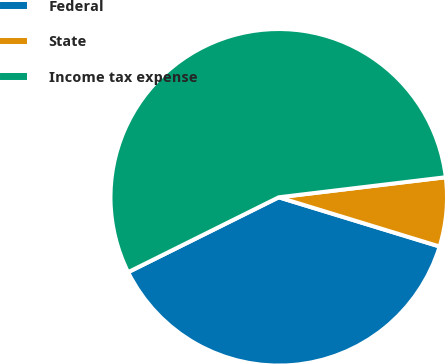Convert chart. <chart><loc_0><loc_0><loc_500><loc_500><pie_chart><fcel>Federal<fcel>State<fcel>Income tax expense<nl><fcel>37.93%<fcel>6.63%<fcel>55.44%<nl></chart> 